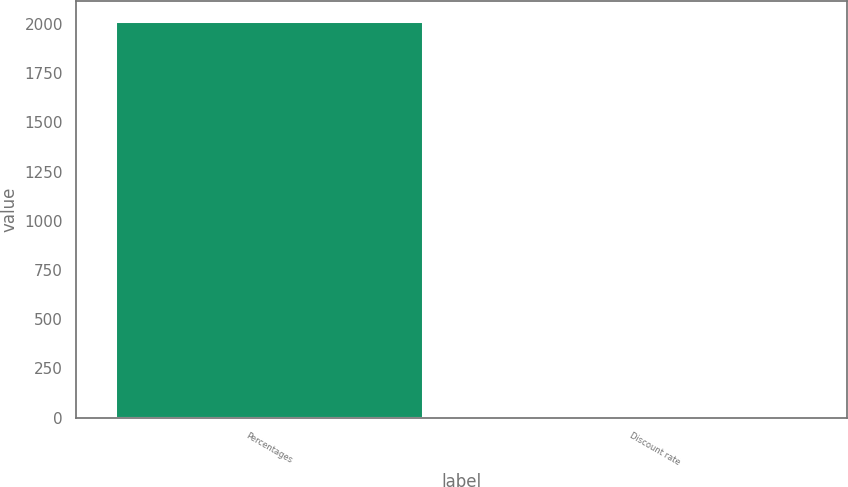Convert chart. <chart><loc_0><loc_0><loc_500><loc_500><bar_chart><fcel>Percentages<fcel>Discount rate<nl><fcel>2016<fcel>4.21<nl></chart> 